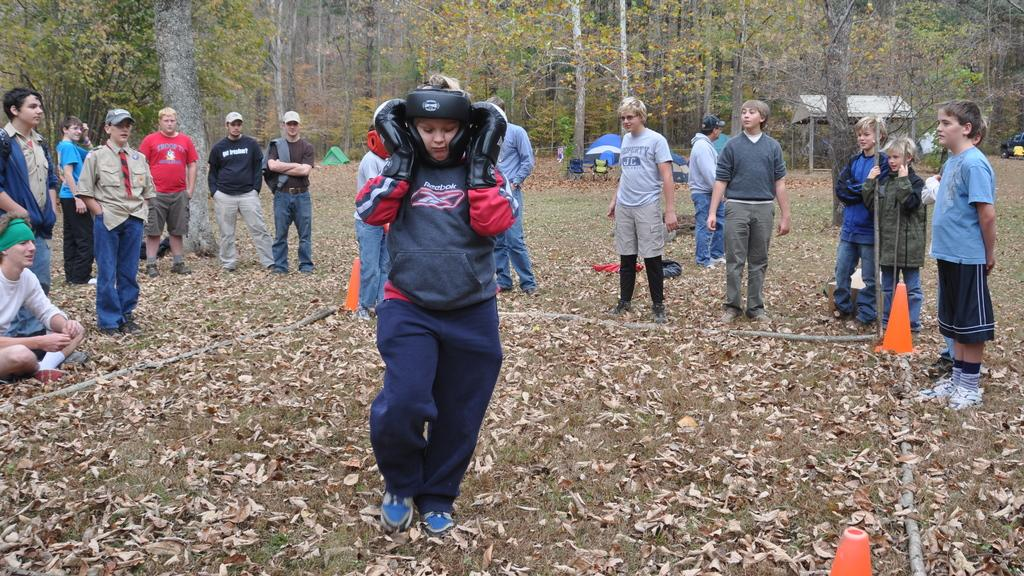What can be seen in the image in terms of human presence? There are people standing in the image. What type of natural elements are present in the image? There are trees and grass in the image. What type of structure is visible in the image? There is a roof and a tent for shelter in the image. What safety precautions are taken in the image? Safety cones are visible in the image. What additional details can be observed in the image? Dried leaves are visible in the image. What type of mailbox can be seen in the image? There is no mailbox present in the image. What emotion does the image evoke in the viewer? The image does not evoke a specific emotion like "thrill" or "disgust"; it simply presents a scene with people, trees, a roof, a tent, safety cones, grass, and dried leaves. 